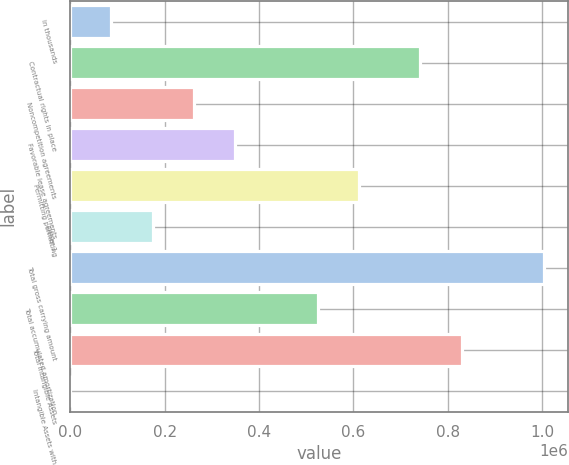Convert chart to OTSL. <chart><loc_0><loc_0><loc_500><loc_500><bar_chart><fcel>in thousands<fcel>Contractual rights in place<fcel>Noncompetition agreements<fcel>Favorable lease agreements<fcel>Permitting permitting<fcel>Other 1<fcel>Total gross carrying amount<fcel>Total accumulated amortization<fcel>Total Intangible Assets<fcel>Intangible Assets with<nl><fcel>87455.7<fcel>742085<fcel>262366<fcel>349820<fcel>612185<fcel>174911<fcel>1.00445e+06<fcel>524730<fcel>829540<fcel>0.73<nl></chart> 